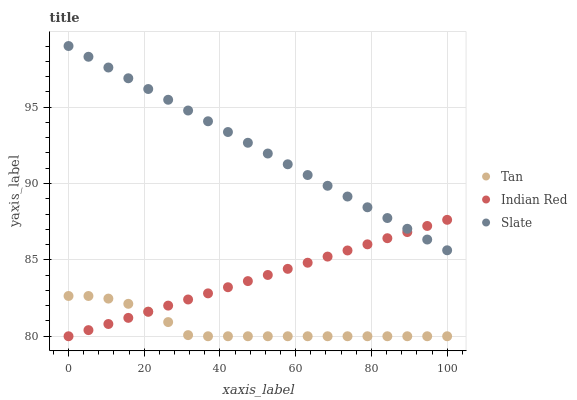Does Tan have the minimum area under the curve?
Answer yes or no. Yes. Does Slate have the maximum area under the curve?
Answer yes or no. Yes. Does Indian Red have the minimum area under the curve?
Answer yes or no. No. Does Indian Red have the maximum area under the curve?
Answer yes or no. No. Is Indian Red the smoothest?
Answer yes or no. Yes. Is Tan the roughest?
Answer yes or no. Yes. Is Slate the smoothest?
Answer yes or no. No. Is Slate the roughest?
Answer yes or no. No. Does Tan have the lowest value?
Answer yes or no. Yes. Does Slate have the lowest value?
Answer yes or no. No. Does Slate have the highest value?
Answer yes or no. Yes. Does Indian Red have the highest value?
Answer yes or no. No. Is Tan less than Slate?
Answer yes or no. Yes. Is Slate greater than Tan?
Answer yes or no. Yes. Does Indian Red intersect Slate?
Answer yes or no. Yes. Is Indian Red less than Slate?
Answer yes or no. No. Is Indian Red greater than Slate?
Answer yes or no. No. Does Tan intersect Slate?
Answer yes or no. No. 